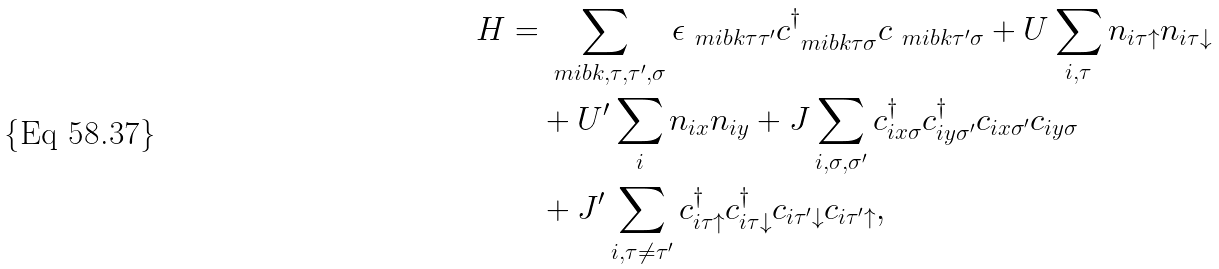Convert formula to latex. <formula><loc_0><loc_0><loc_500><loc_500>H = & \sum _ { \ m i b { k } , \tau , \tau ^ { \prime } , \sigma } \epsilon _ { \ m i b { k } \tau \tau ^ { \prime } } c ^ { \dagger } _ { \ m i b { k } \tau \sigma } c _ { \ m i b { k } \tau ^ { \prime } \sigma } + U \sum _ { i , \tau } n _ { i \tau \uparrow } n _ { i \tau \downarrow } \\ & + U ^ { \prime } \sum _ { i } n _ { i x } n _ { i y } + J \sum _ { i , \sigma , \sigma ^ { \prime } } c ^ { \dagger } _ { i x \sigma } c ^ { \dagger } _ { i y \sigma ^ { \prime } } c _ { i x \sigma ^ { \prime } } c _ { i y \sigma } \\ & + J ^ { \prime } \sum _ { i , \tau \ne \tau ^ { \prime } } c ^ { \dagger } _ { i \tau \uparrow } c ^ { \dagger } _ { i \tau \downarrow } c _ { i \tau ^ { \prime } \downarrow } c _ { i \tau ^ { \prime } \uparrow } ,</formula> 